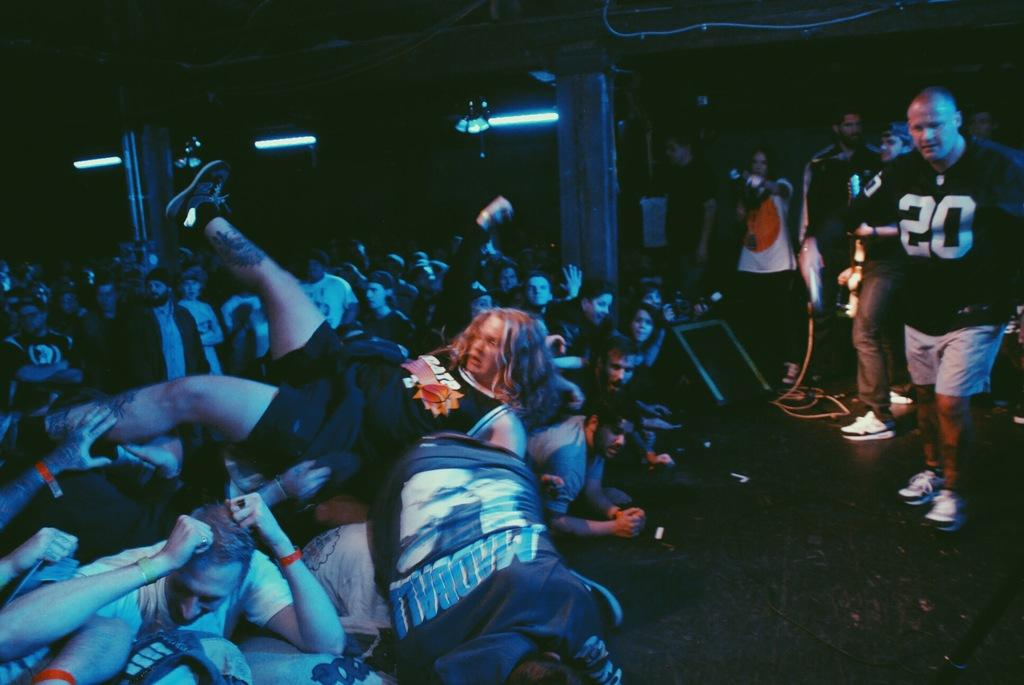<image>
Relay a brief, clear account of the picture shown. Group of people and a man wearing a shirt which says the number 20. 